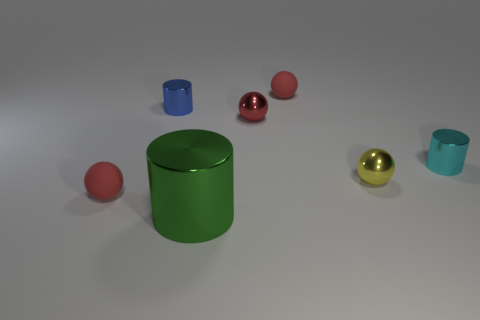Subtract all red balls. How many were subtracted if there are1red balls left? 2 Subtract all red blocks. How many red spheres are left? 3 Subtract all small red shiny spheres. How many spheres are left? 3 Subtract all yellow balls. How many balls are left? 3 Subtract all purple balls. Subtract all green cubes. How many balls are left? 4 Add 2 small blue balls. How many objects exist? 9 Subtract all spheres. How many objects are left? 3 Add 7 tiny rubber objects. How many tiny rubber objects are left? 9 Add 2 cyan shiny objects. How many cyan shiny objects exist? 3 Subtract 0 purple cylinders. How many objects are left? 7 